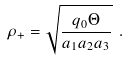<formula> <loc_0><loc_0><loc_500><loc_500>\rho _ { + } = \sqrt { \frac { q _ { 0 } \Theta } { a _ { 1 } a _ { 2 } a _ { 3 } } } \ .</formula> 